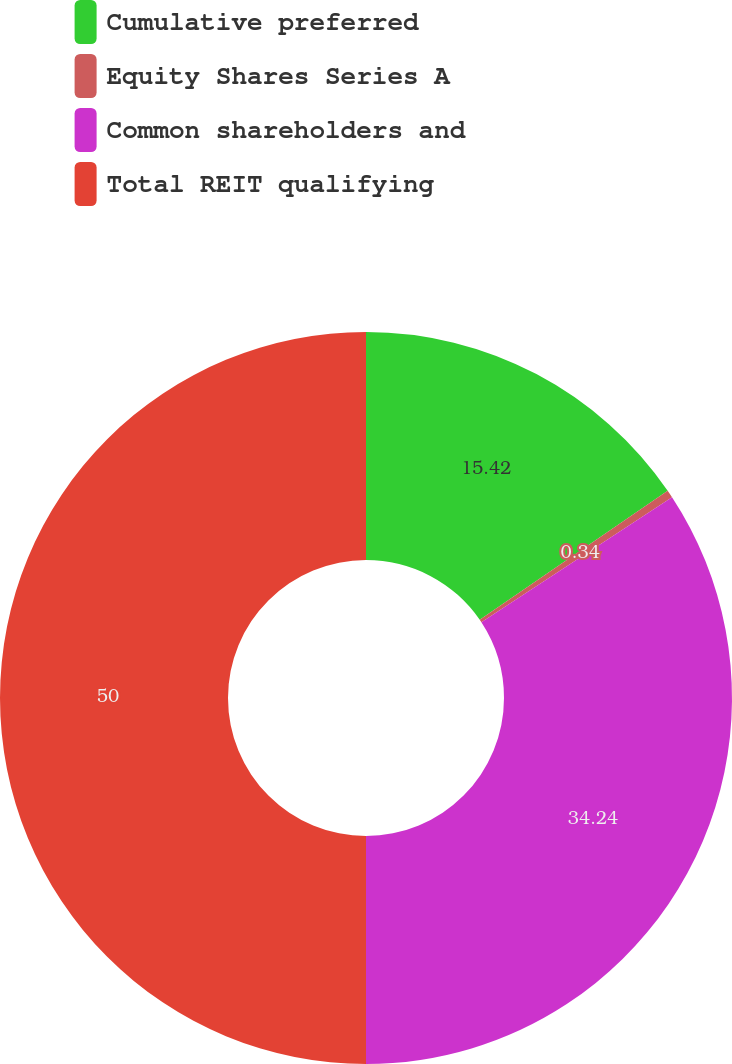Convert chart. <chart><loc_0><loc_0><loc_500><loc_500><pie_chart><fcel>Cumulative preferred<fcel>Equity Shares Series A<fcel>Common shareholders and<fcel>Total REIT qualifying<nl><fcel>15.42%<fcel>0.34%<fcel>34.24%<fcel>50.0%<nl></chart> 